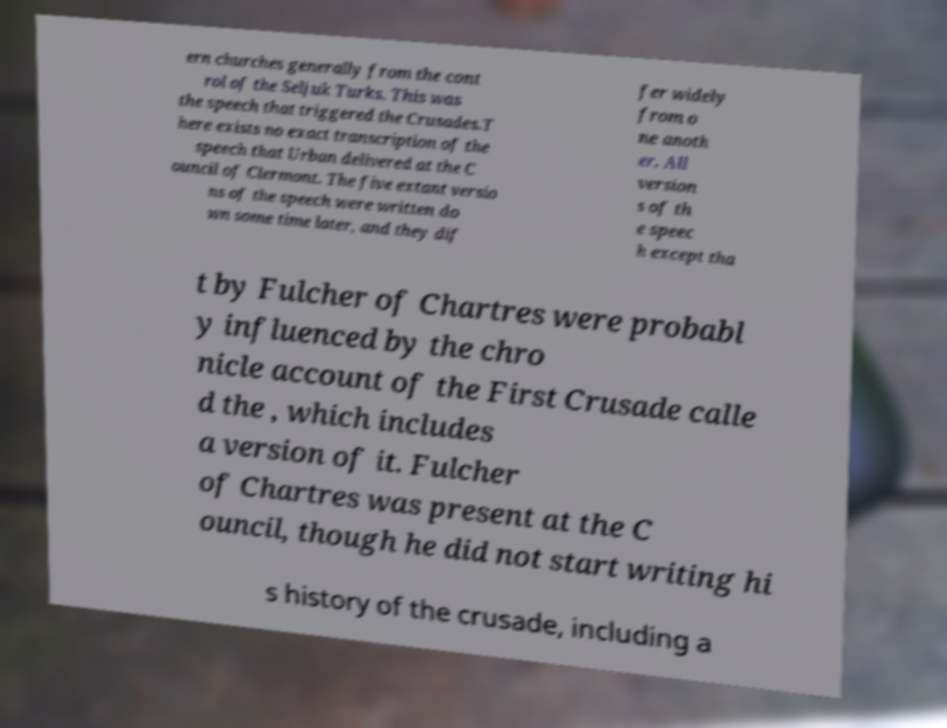For documentation purposes, I need the text within this image transcribed. Could you provide that? ern churches generally from the cont rol of the Seljuk Turks. This was the speech that triggered the Crusades.T here exists no exact transcription of the speech that Urban delivered at the C ouncil of Clermont. The five extant versio ns of the speech were written do wn some time later, and they dif fer widely from o ne anoth er. All version s of th e speec h except tha t by Fulcher of Chartres were probabl y influenced by the chro nicle account of the First Crusade calle d the , which includes a version of it. Fulcher of Chartres was present at the C ouncil, though he did not start writing hi s history of the crusade, including a 